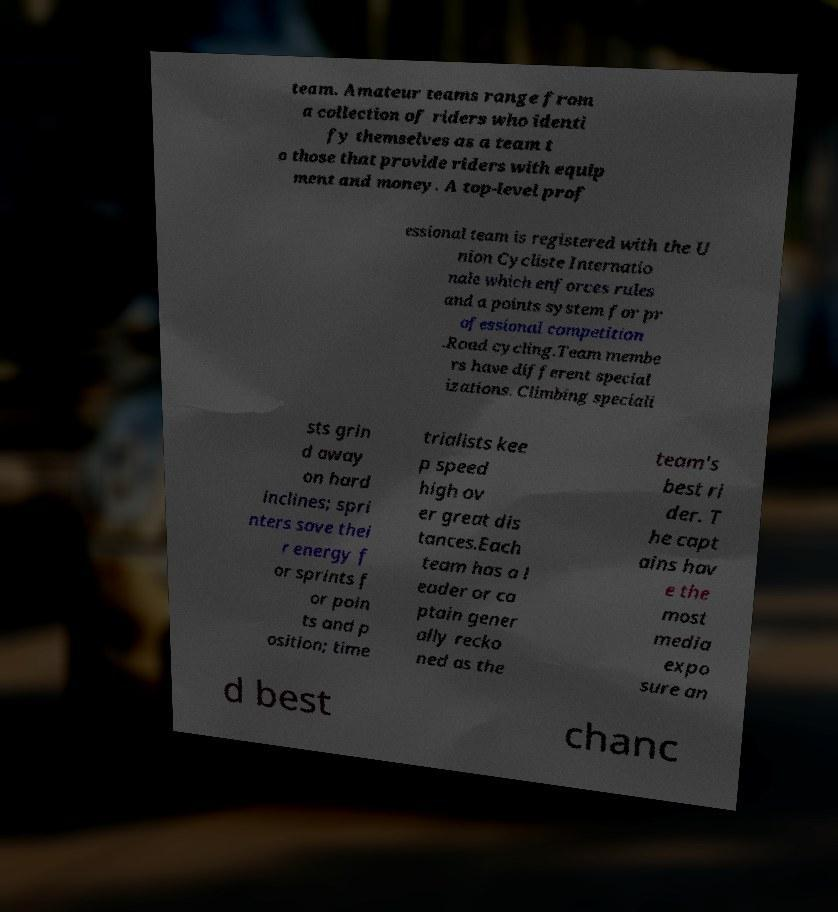Please identify and transcribe the text found in this image. team. Amateur teams range from a collection of riders who identi fy themselves as a team t o those that provide riders with equip ment and money. A top-level prof essional team is registered with the U nion Cycliste Internatio nale which enforces rules and a points system for pr ofessional competition .Road cycling.Team membe rs have different special izations. Climbing speciali sts grin d away on hard inclines; spri nters save thei r energy f or sprints f or poin ts and p osition; time trialists kee p speed high ov er great dis tances.Each team has a l eader or ca ptain gener ally recko ned as the team's best ri der. T he capt ains hav e the most media expo sure an d best chanc 